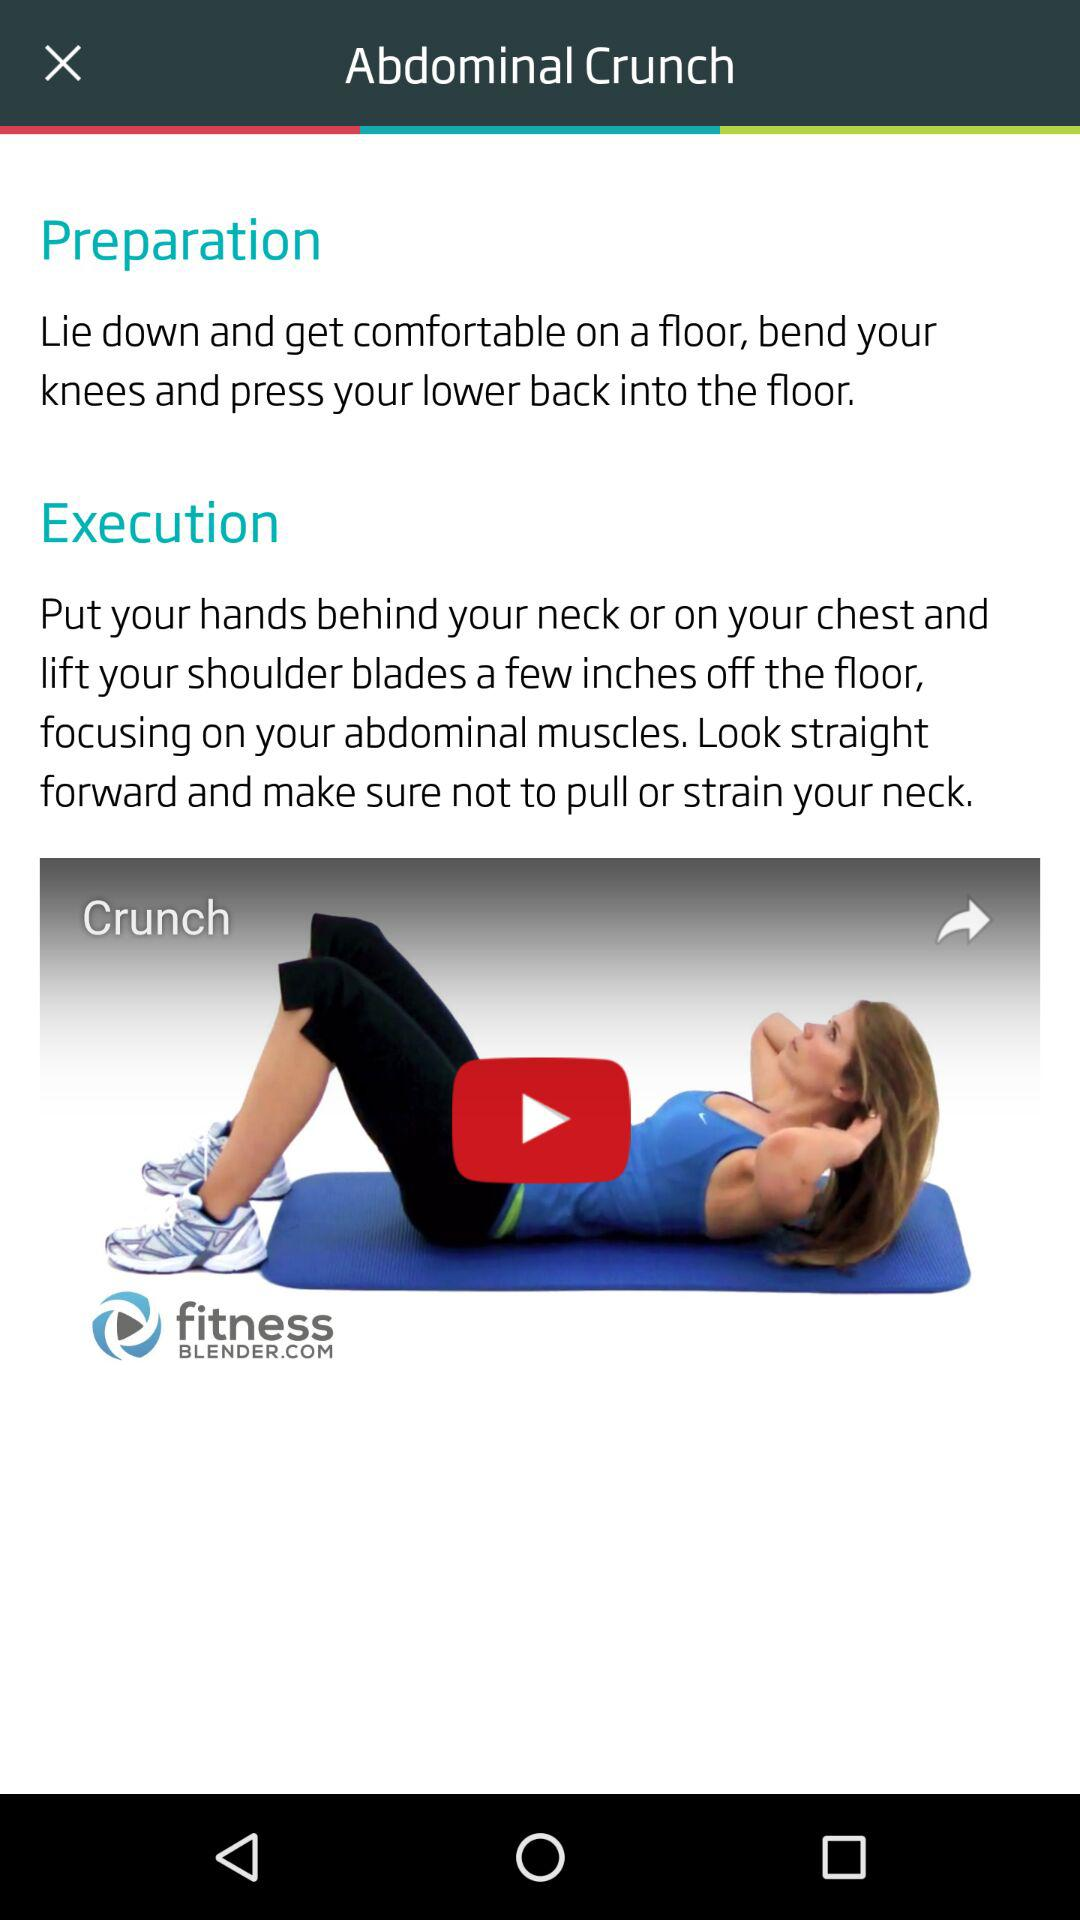How many steps are there in the execution of the abdominal crunch exercise?
Answer the question using a single word or phrase. 2 